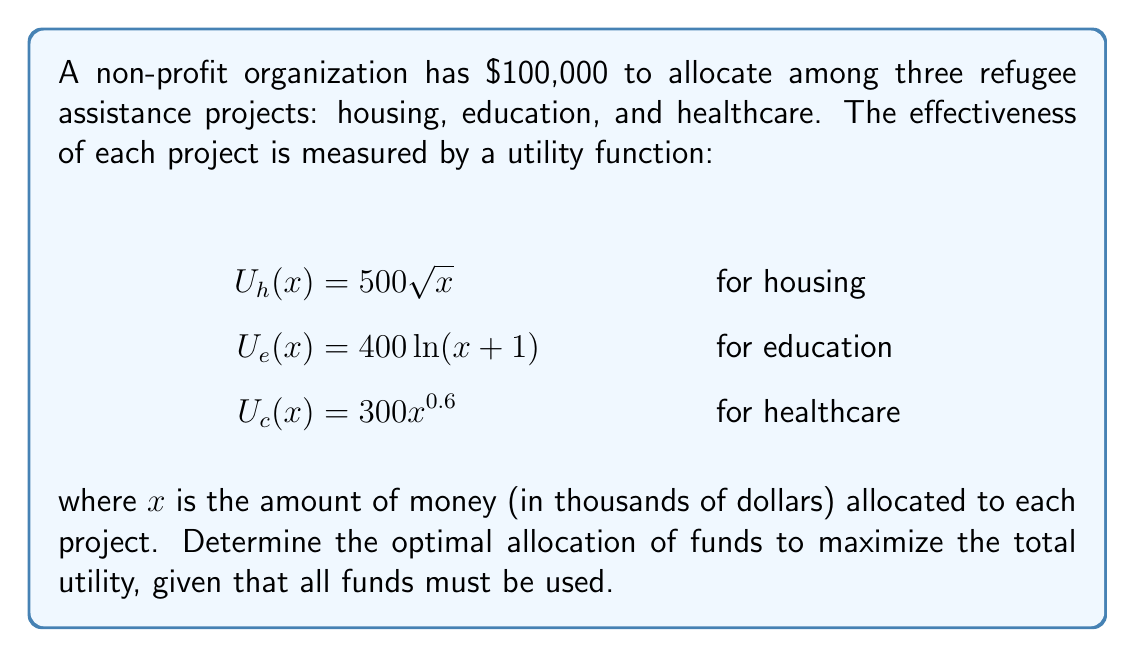What is the answer to this math problem? To solve this problem, we'll use the method of Lagrange multipliers:

1) Let $x$, $y$, and $z$ represent the funds (in thousands) allocated to housing, education, and healthcare respectively.

2) Our objective function is the total utility:
   $$U(x,y,z) = 500\sqrt{x} + 400\ln(y+1) + 300z^{0.6}$$

3) The constraint is:
   $$x + y + z = 100$$

4) Form the Lagrangian:
   $$L(x,y,z,\lambda) = 500\sqrt{x} + 400\ln(y+1) + 300z^{0.6} - \lambda(x + y + z - 100)$$

5) Take partial derivatives and set them to zero:
   $$\frac{\partial L}{\partial x} = \frac{250}{\sqrt{x}} - \lambda = 0$$
   $$\frac{\partial L}{\partial y} = \frac{400}{y+1} - \lambda = 0$$
   $$\frac{\partial L}{\partial z} = 180z^{-0.4} - \lambda = 0$$
   $$\frac{\partial L}{\partial \lambda} = x + y + z - 100 = 0$$

6) From these equations, we can derive:
   $$\frac{250}{\sqrt{x}} = \frac{400}{y+1} = 180z^{-0.4}$$

7) Let's call this common value $\lambda$. Then:
   $$x = \frac{62500}{\lambda^2}, y = \frac{400}{\lambda} - 1, z = (\frac{180}{\lambda})^{2.5}$$

8) Substitute these into the constraint equation:
   $$\frac{62500}{\lambda^2} + \frac{400}{\lambda} - 1 + (\frac{180}{\lambda})^{2.5} = 100$$

9) This equation can be solved numerically to find $\lambda \approx 25.8307$.

10) Substituting this value back gives us:
    $$x \approx 93.75, y \approx 14.49, z \approx 41.76$$

11) Rounding to the nearest thousand dollars:
    Housing: $44,000
    Education: $14,000
    Healthcare: $42,000
Answer: The optimal allocation is approximately:
Housing: $44,000
Education: $14,000
Healthcare: $42,000 